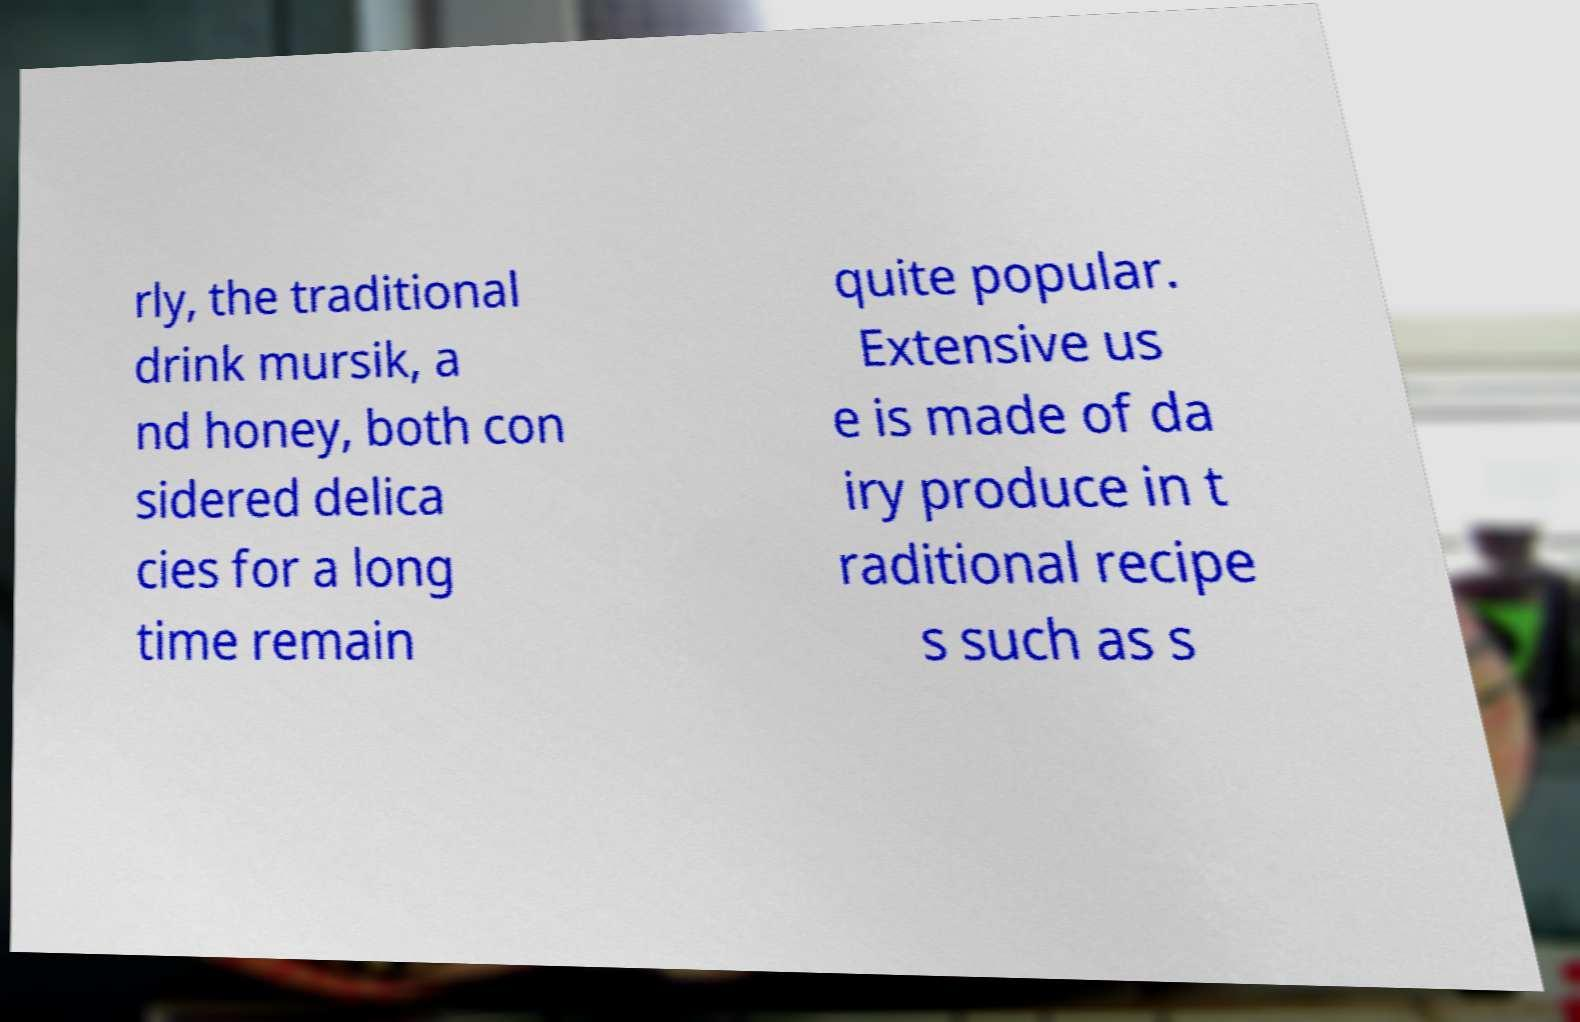Can you read and provide the text displayed in the image?This photo seems to have some interesting text. Can you extract and type it out for me? rly, the traditional drink mursik, a nd honey, both con sidered delica cies for a long time remain quite popular. Extensive us e is made of da iry produce in t raditional recipe s such as s 